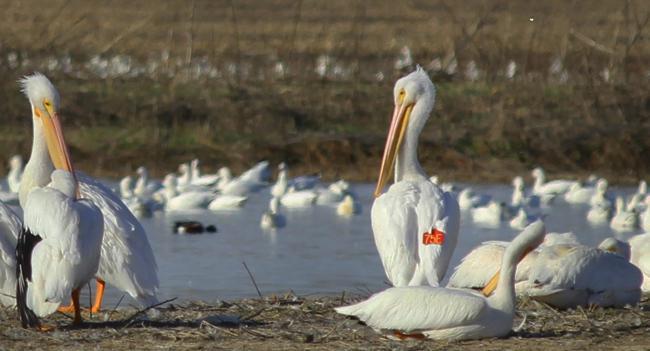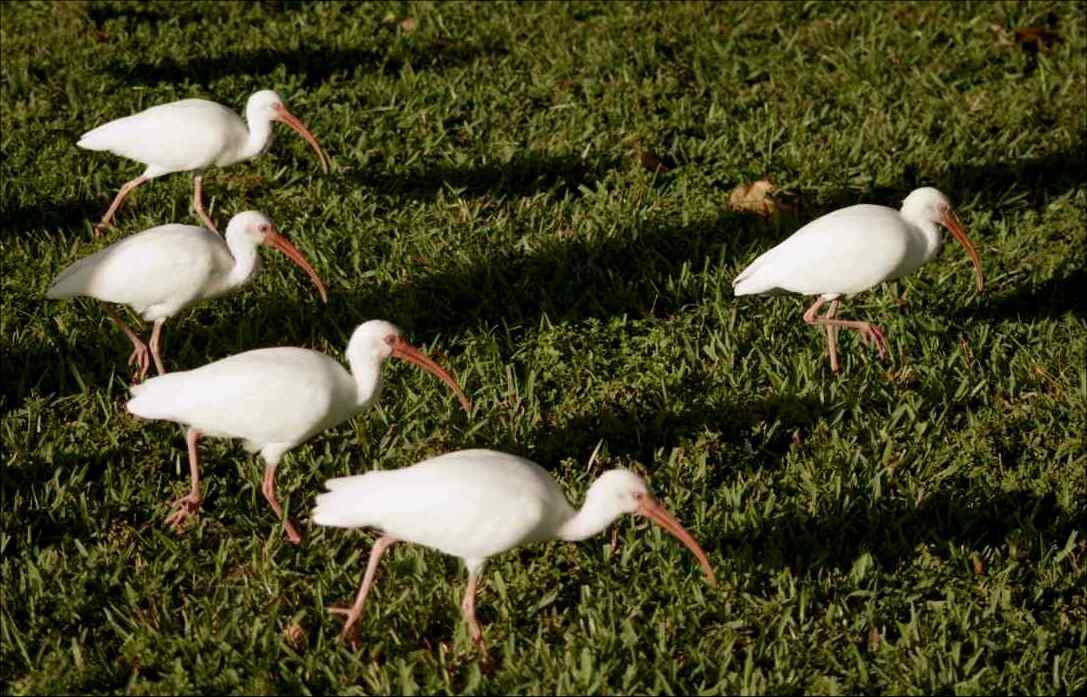The first image is the image on the left, the second image is the image on the right. Examine the images to the left and right. Is the description "there is one bird in the right side photo" accurate? Answer yes or no. No. The first image is the image on the left, the second image is the image on the right. Evaluate the accuracy of this statement regarding the images: "There is only one bird in one of the images.". Is it true? Answer yes or no. No. 